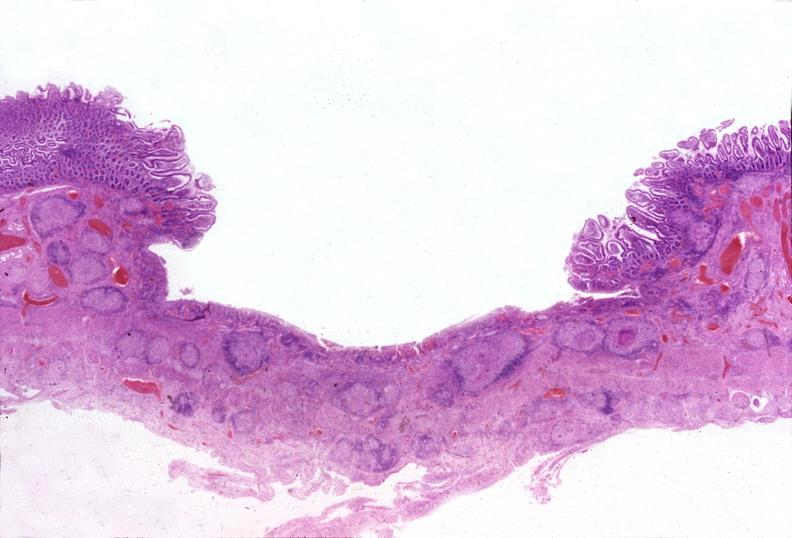where is this from?
Answer the question using a single word or phrase. Gastrointestinal system 